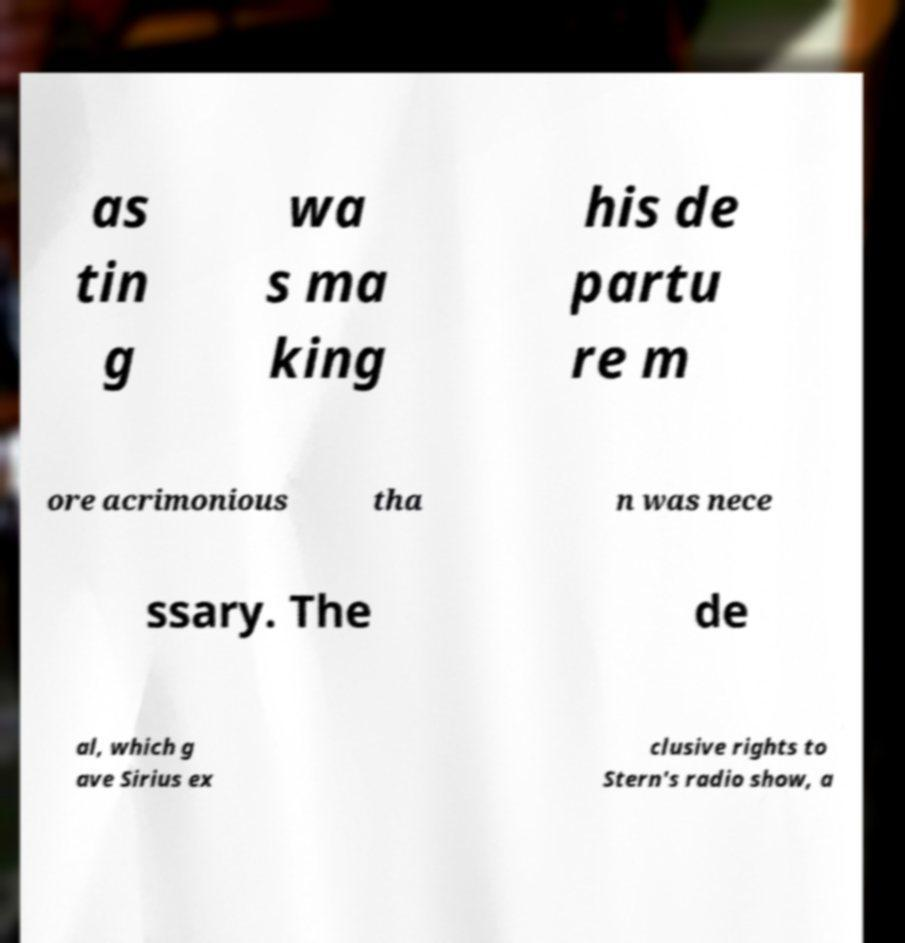Could you assist in decoding the text presented in this image and type it out clearly? as tin g wa s ma king his de partu re m ore acrimonious tha n was nece ssary. The de al, which g ave Sirius ex clusive rights to Stern's radio show, a 